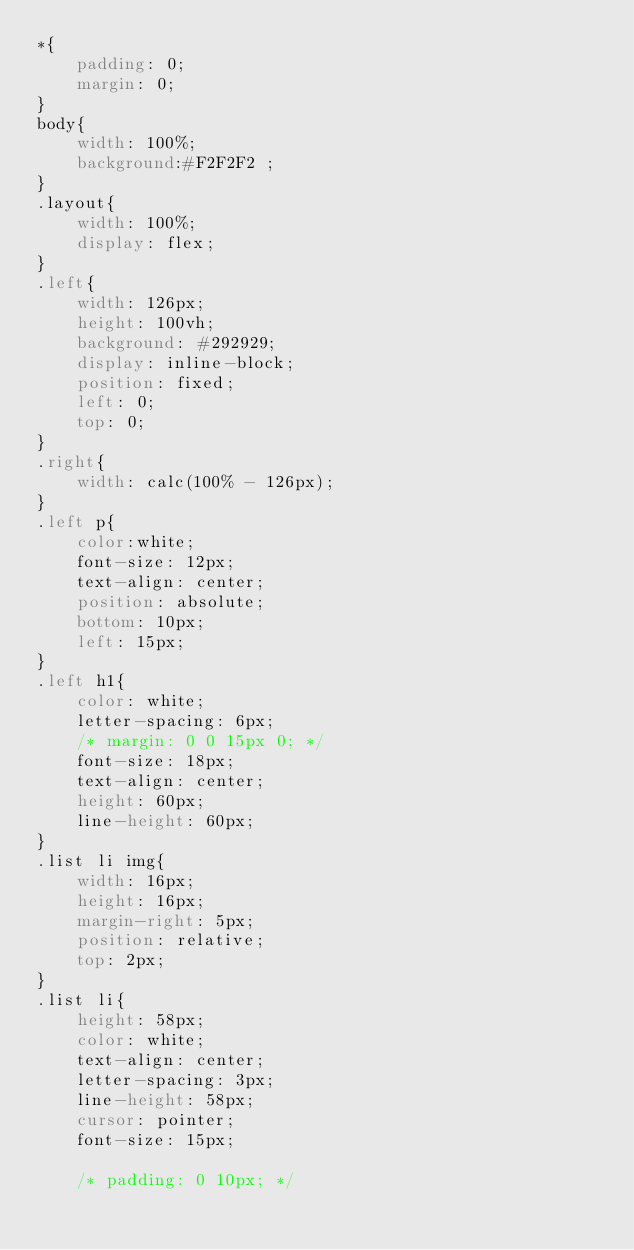<code> <loc_0><loc_0><loc_500><loc_500><_CSS_>*{
    padding: 0;
    margin: 0;   
}
body{
    width: 100%;
    background:#F2F2F2 ;
}
.layout{
    width: 100%;
    display: flex;
}
.left{
    width: 126px;
    height: 100vh;
    background: #292929;
    display: inline-block;
    position: fixed;
    left: 0;
    top: 0;
}
.right{
    width: calc(100% - 126px); 
}
.left p{
    color:white;
    font-size: 12px;
    text-align: center;
    position: absolute;
    bottom: 10px;
    left: 15px;
}
.left h1{
    color: white;
    letter-spacing: 6px;
    /* margin: 0 0 15px 0; */
    font-size: 18px;
    text-align: center;
    height: 60px;
    line-height: 60px;
}
.list li img{
    width: 16px;
    height: 16px;
    margin-right: 5px;
    position: relative;
    top: 2px;
}
.list li{
    height: 58px;
    color: white;
    text-align: center;
    letter-spacing: 3px;
    line-height: 58px;
    cursor: pointer;
    font-size: 15px;

    /* padding: 0 10px; */</code> 